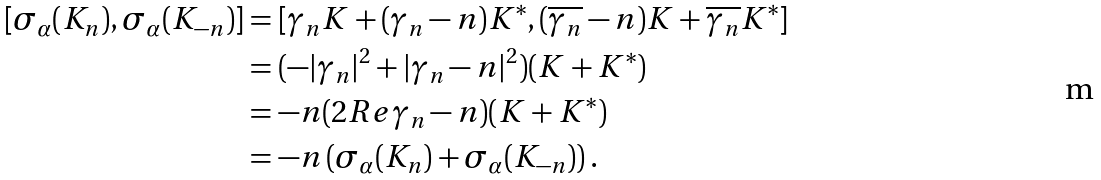<formula> <loc_0><loc_0><loc_500><loc_500>[ \sigma _ { \alpha } ( K _ { n } ) , \sigma _ { \alpha } ( K _ { - n } ) ] & = [ \gamma _ { n } K + ( \gamma _ { n } - n ) K ^ { * } , ( \overline { \gamma _ { n } } - n ) K + \overline { \gamma _ { n } } K ^ { * } ] \\ & = ( - | \gamma _ { n } | ^ { 2 } + | \gamma _ { n } - n | ^ { 2 } ) ( K + K ^ { * } ) \\ & = - n ( 2 R e \gamma _ { n } - n ) ( K + K ^ { * } ) \\ & = - n \left ( \sigma _ { \alpha } ( K _ { n } ) + \sigma _ { \alpha } ( K _ { - n } ) \right ) .</formula> 